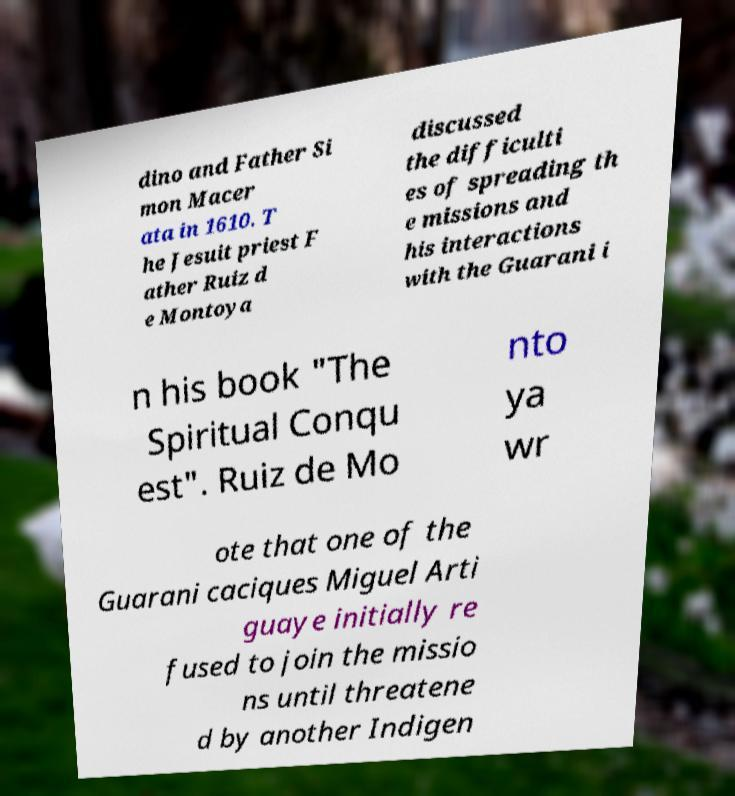Could you assist in decoding the text presented in this image and type it out clearly? dino and Father Si mon Macer ata in 1610. T he Jesuit priest F ather Ruiz d e Montoya discussed the difficulti es of spreading th e missions and his interactions with the Guarani i n his book "The Spiritual Conqu est". Ruiz de Mo nto ya wr ote that one of the Guarani caciques Miguel Arti guaye initially re fused to join the missio ns until threatene d by another Indigen 